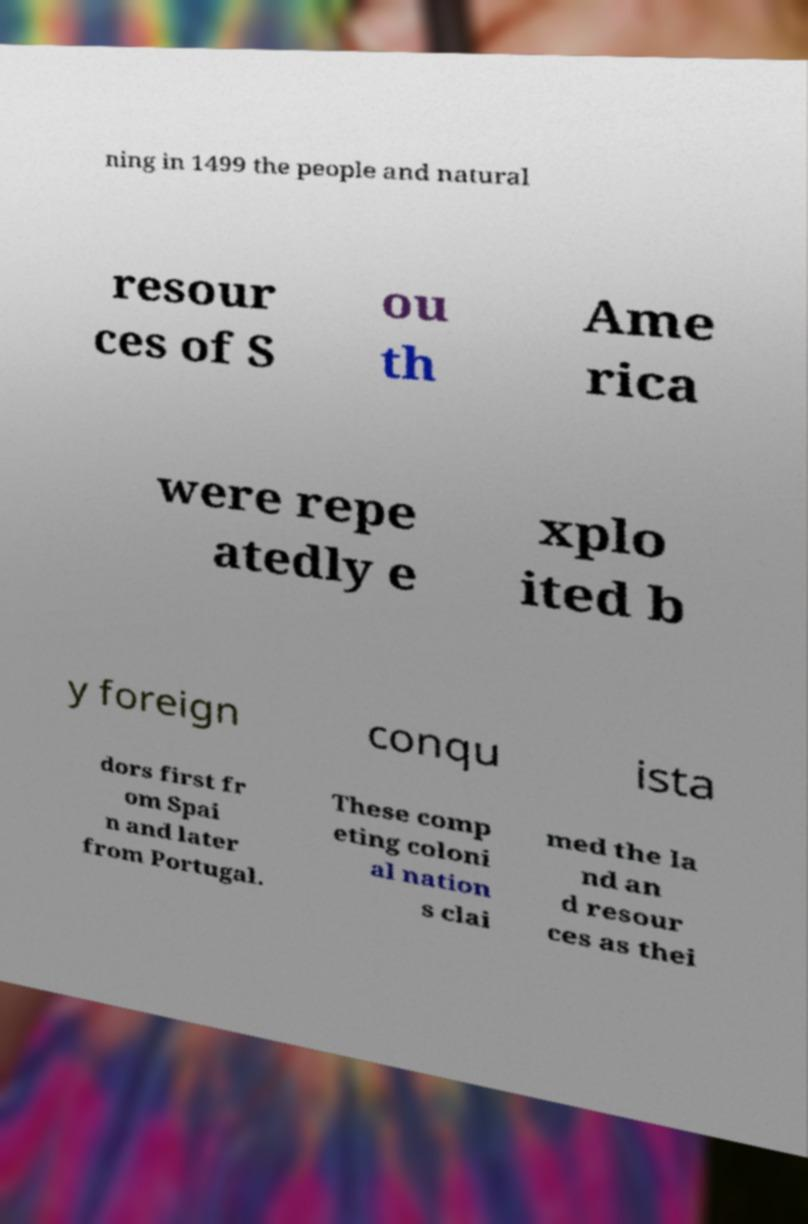I need the written content from this picture converted into text. Can you do that? ning in 1499 the people and natural resour ces of S ou th Ame rica were repe atedly e xplo ited b y foreign conqu ista dors first fr om Spai n and later from Portugal. These comp eting coloni al nation s clai med the la nd an d resour ces as thei 